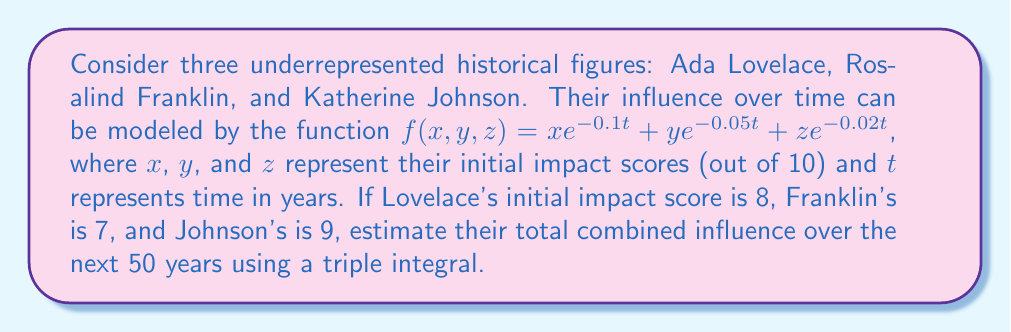Provide a solution to this math problem. To solve this problem, we'll follow these steps:

1) First, we need to set up the triple integral. The function given is:

   $f(x,y,z) = xe^{-0.1t} + ye^{-0.05t} + ze^{-0.02t}$

   Where $x = 8$ (Lovelace), $y = 7$ (Franklin), and $z = 9$ (Johnson).

2) Substituting these values:

   $f(t) = 8e^{-0.1t} + 7e^{-0.05t} + 9e^{-0.02t}$

3) To find the total influence over 50 years, we need to integrate this function from $t = 0$ to $t = 50$:

   $$\int_0^{50} (8e^{-0.1t} + 7e^{-0.05t} + 9e^{-0.02t}) dt$$

4) We can split this into three integrals:

   $$8\int_0^{50} e^{-0.1t} dt + 7\int_0^{50} e^{-0.05t} dt + 9\int_0^{50} e^{-0.02t} dt$$

5) Using the antiderivative of $e^{at}$, which is $\frac{1}{a}e^{at}$, we get:

   $$8[-10e^{-0.1t}]_0^{50} + 7[-20e^{-0.05t}]_0^{50} + 9[-50e^{-0.02t}]_0^{50}$$

6) Evaluating at the limits:

   $$8[-10(e^{-5} - 1)] + 7[-20(e^{-2.5} - 1)] + 9[-50(e^{-1} - 1)]$$

7) Calculating:

   $$8[10 - 10e^{-5}] + 7[20 - 20e^{-2.5}] + 9[50 - 50e^{-1}]$$
   $$\approx 79.93 + 139.86 + 331.13$$
   $$\approx 550.92$$

Thus, the total combined influence over 50 years is approximately 550.92 units.
Answer: 550.92 units of influence 